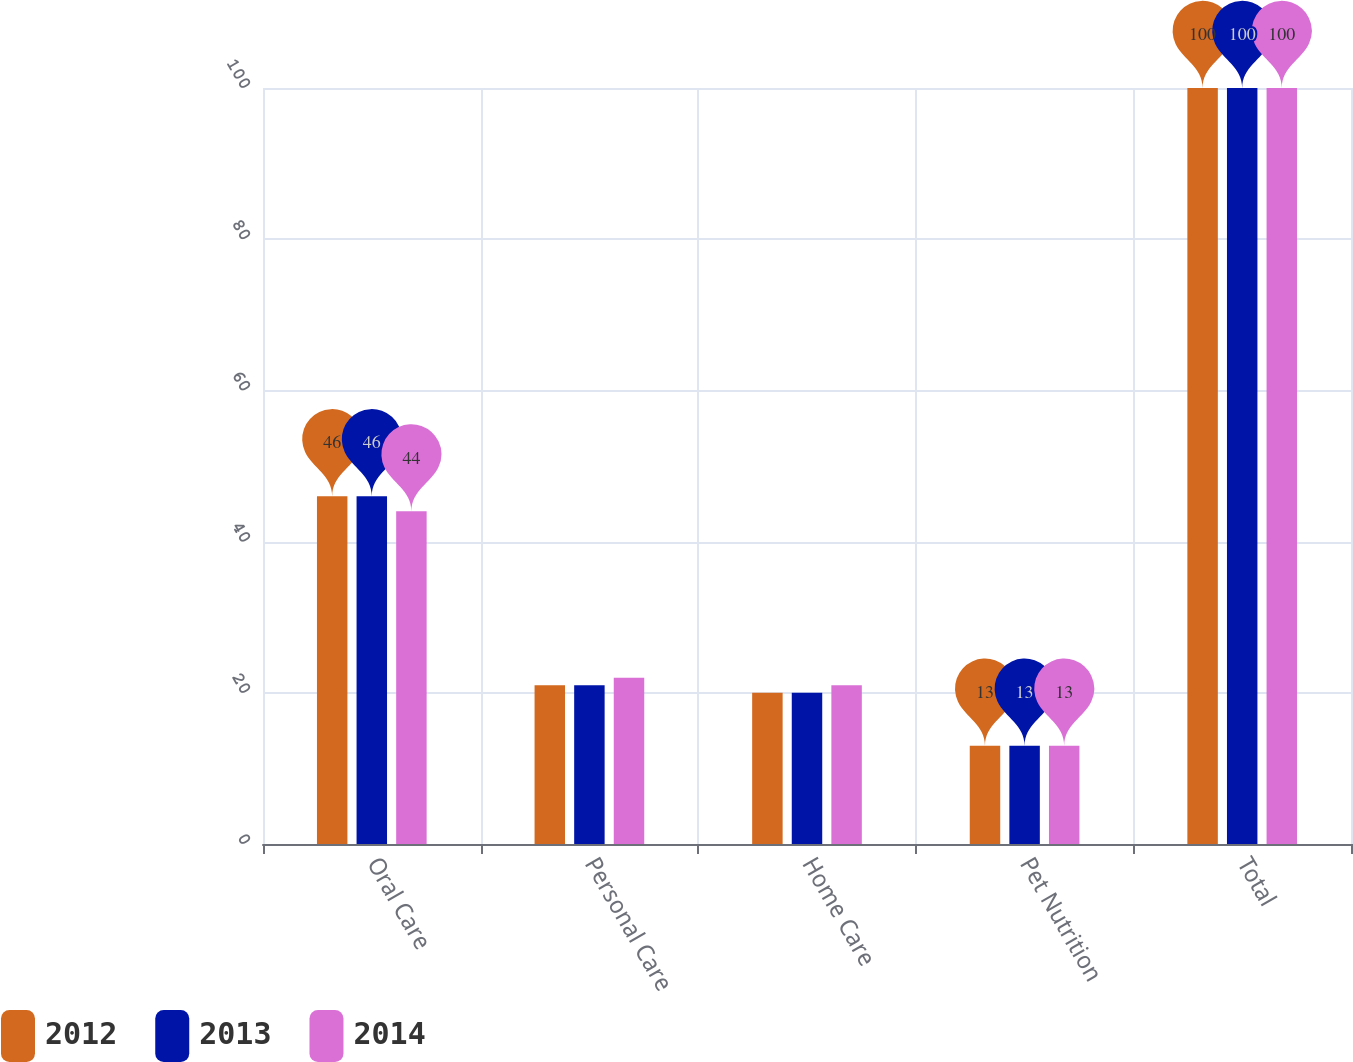Convert chart. <chart><loc_0><loc_0><loc_500><loc_500><stacked_bar_chart><ecel><fcel>Oral Care<fcel>Personal Care<fcel>Home Care<fcel>Pet Nutrition<fcel>Total<nl><fcel>2012<fcel>46<fcel>21<fcel>20<fcel>13<fcel>100<nl><fcel>2013<fcel>46<fcel>21<fcel>20<fcel>13<fcel>100<nl><fcel>2014<fcel>44<fcel>22<fcel>21<fcel>13<fcel>100<nl></chart> 